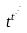Convert formula to latex. <formula><loc_0><loc_0><loc_500><loc_500>t ^ { t ^ { \cdot ^ { \cdot ^ { \cdot } } } }</formula> 